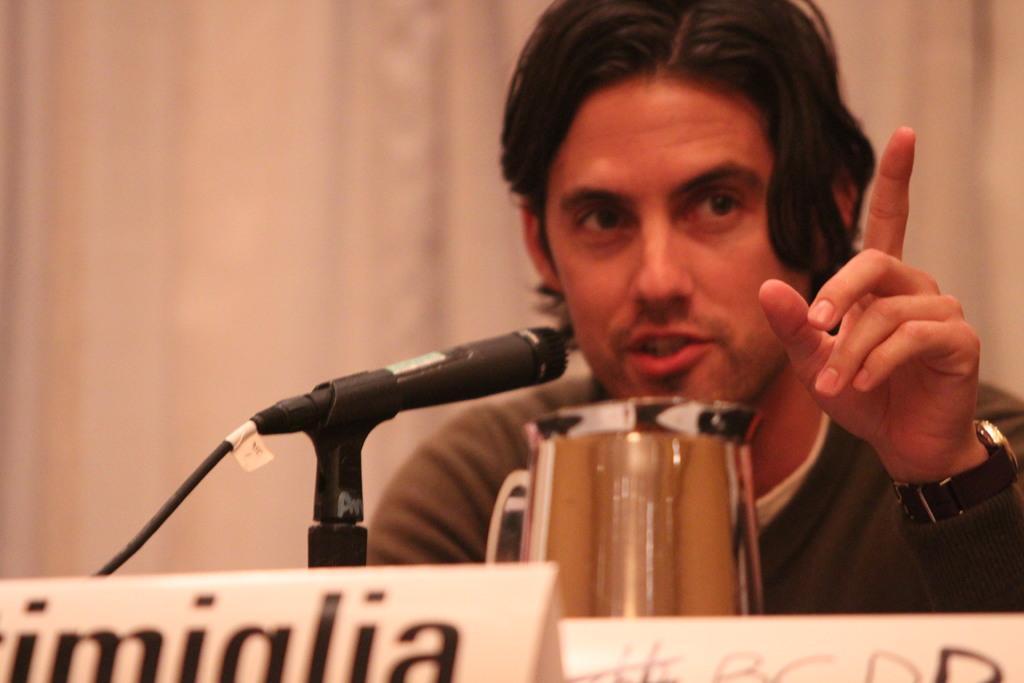Describe this image in one or two sentences. There is a person wearing watch is speaking. In front of him there is a mic with stand and a jug. Also there are some boards in front of him. 